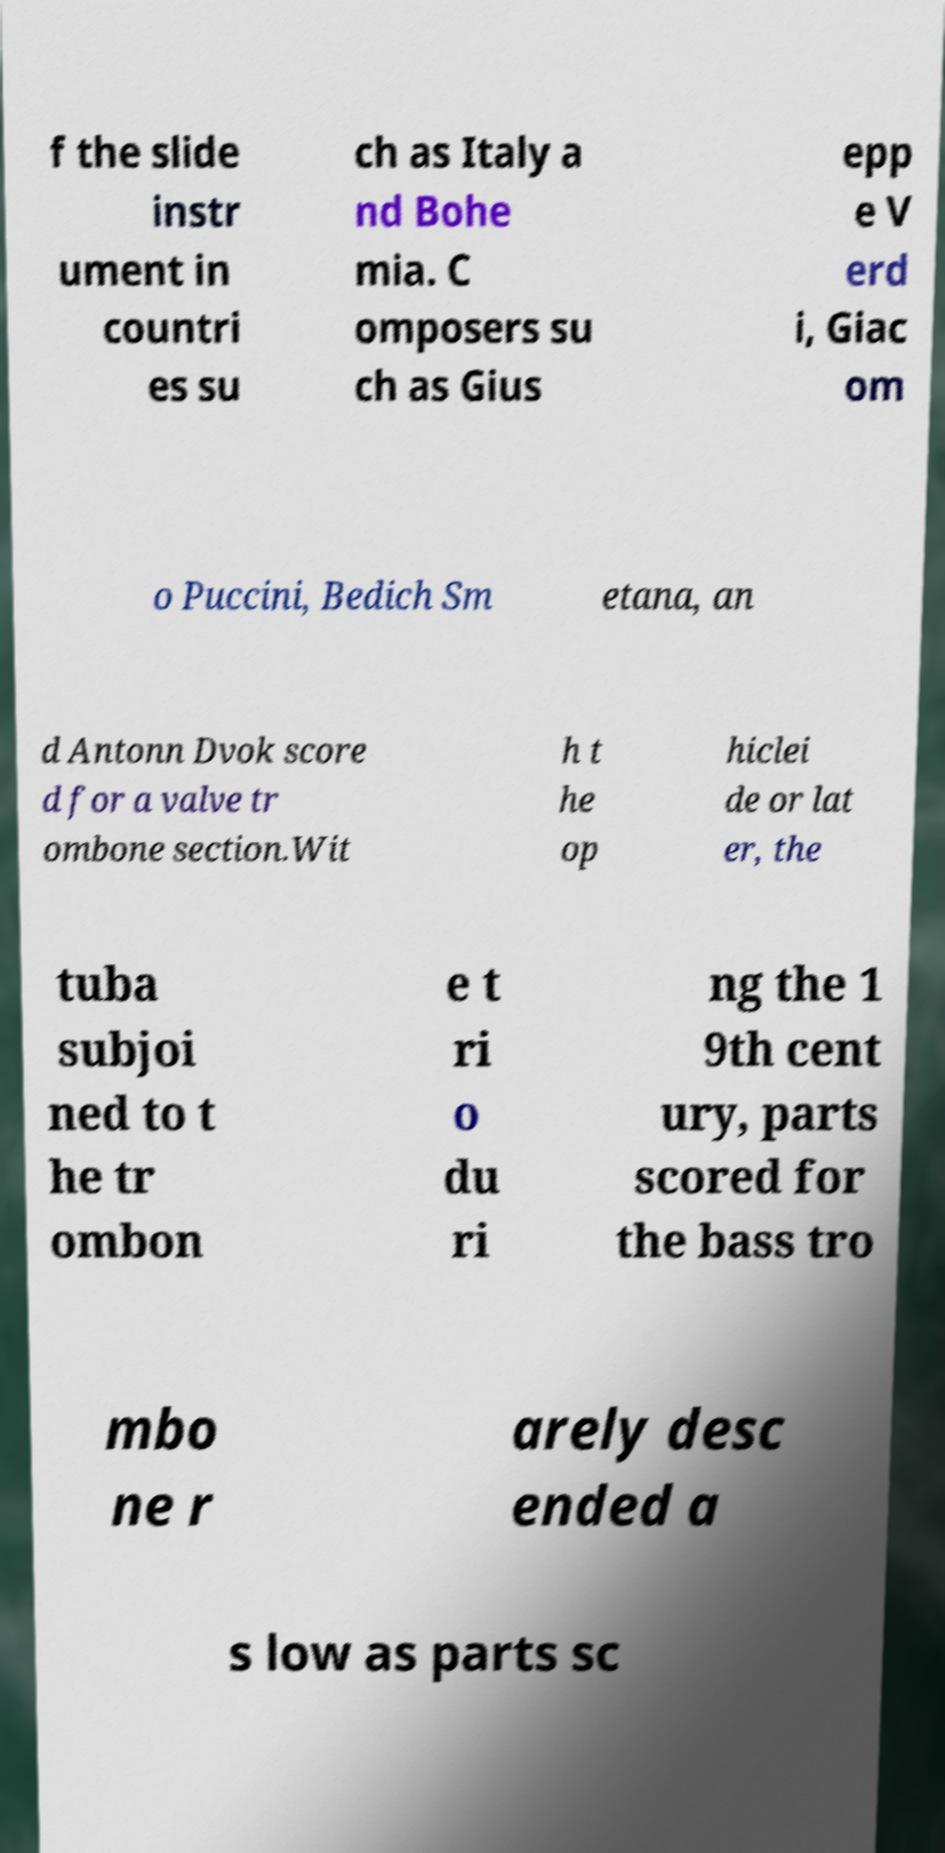Could you extract and type out the text from this image? f the slide instr ument in countri es su ch as Italy a nd Bohe mia. C omposers su ch as Gius epp e V erd i, Giac om o Puccini, Bedich Sm etana, an d Antonn Dvok score d for a valve tr ombone section.Wit h t he op hiclei de or lat er, the tuba subjoi ned to t he tr ombon e t ri o du ri ng the 1 9th cent ury, parts scored for the bass tro mbo ne r arely desc ended a s low as parts sc 